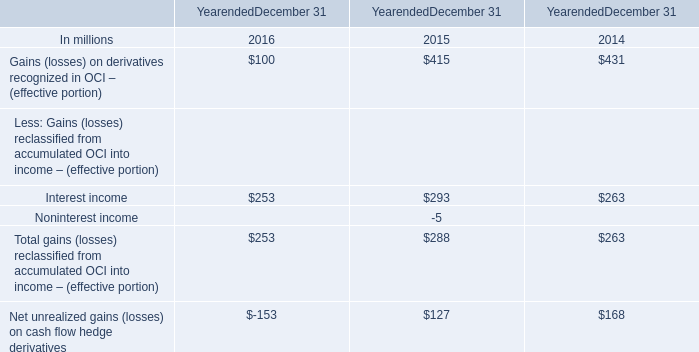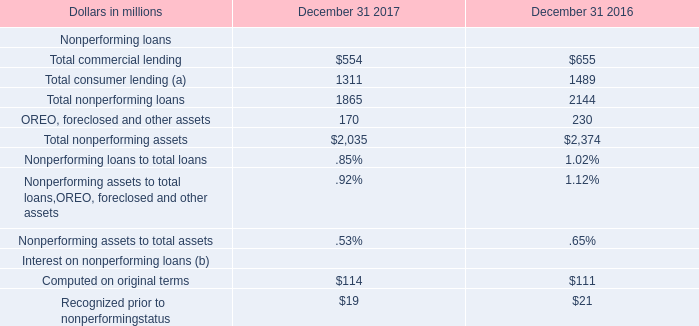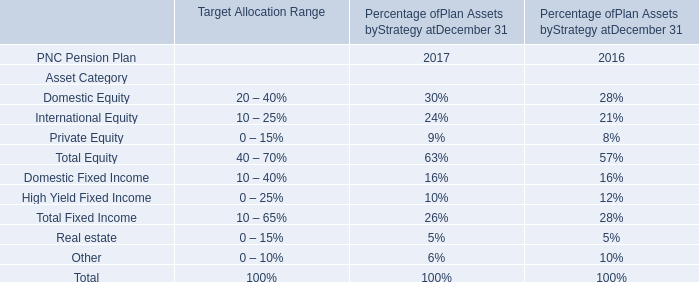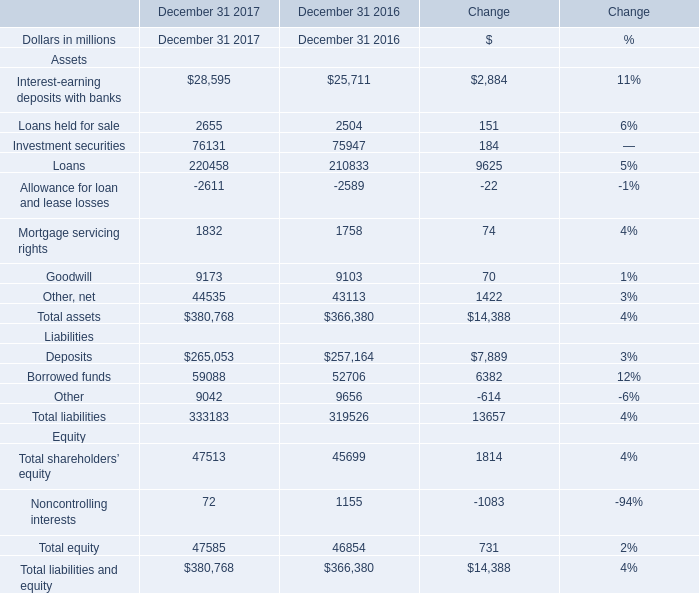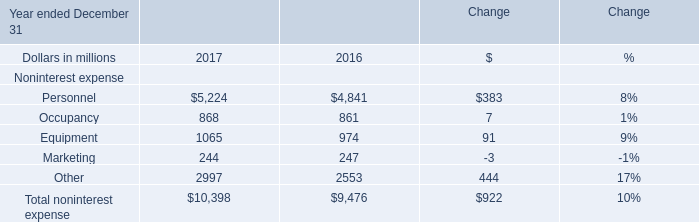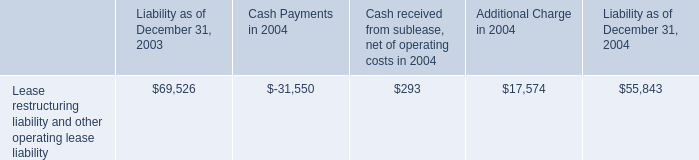What was the average value of the Equipment in the years where Personnel is positive? (in million) 
Computations: ((1065 + 974) / 2)
Answer: 1019.5. 